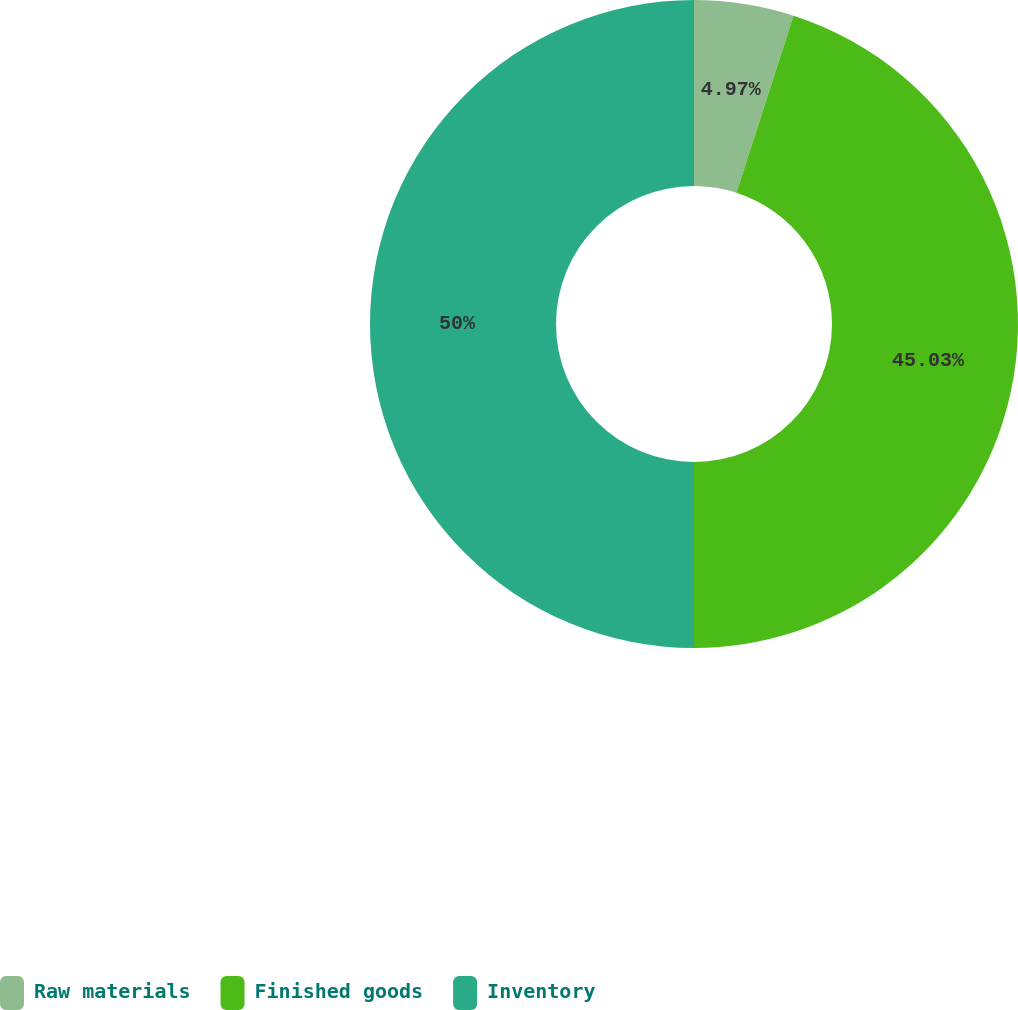Convert chart. <chart><loc_0><loc_0><loc_500><loc_500><pie_chart><fcel>Raw materials<fcel>Finished goods<fcel>Inventory<nl><fcel>4.97%<fcel>45.03%<fcel>50.0%<nl></chart> 